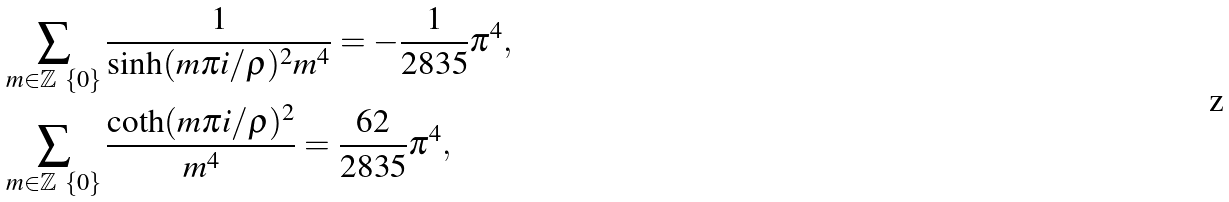<formula> <loc_0><loc_0><loc_500><loc_500>& \sum _ { m \in \mathbb { Z } \ \{ 0 \} } \frac { 1 } { \sinh ( m \pi i / \rho ) ^ { 2 } m ^ { 4 } } = - \frac { 1 } { 2 8 3 5 } \pi ^ { 4 } , \\ & \sum _ { m \in \mathbb { Z } \ \{ 0 \} } \frac { \coth ( m \pi i / \rho ) ^ { 2 } } { m ^ { 4 } } = \frac { 6 2 } { 2 8 3 5 } \pi ^ { 4 } ,</formula> 